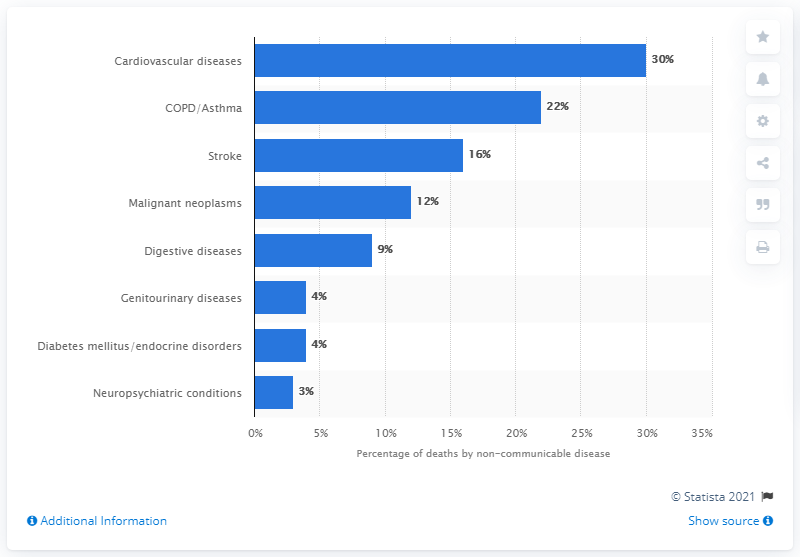Mention a couple of crucial points in this snapshot. In 2010, cardiovascular diseases were the leading cause of death in India. 